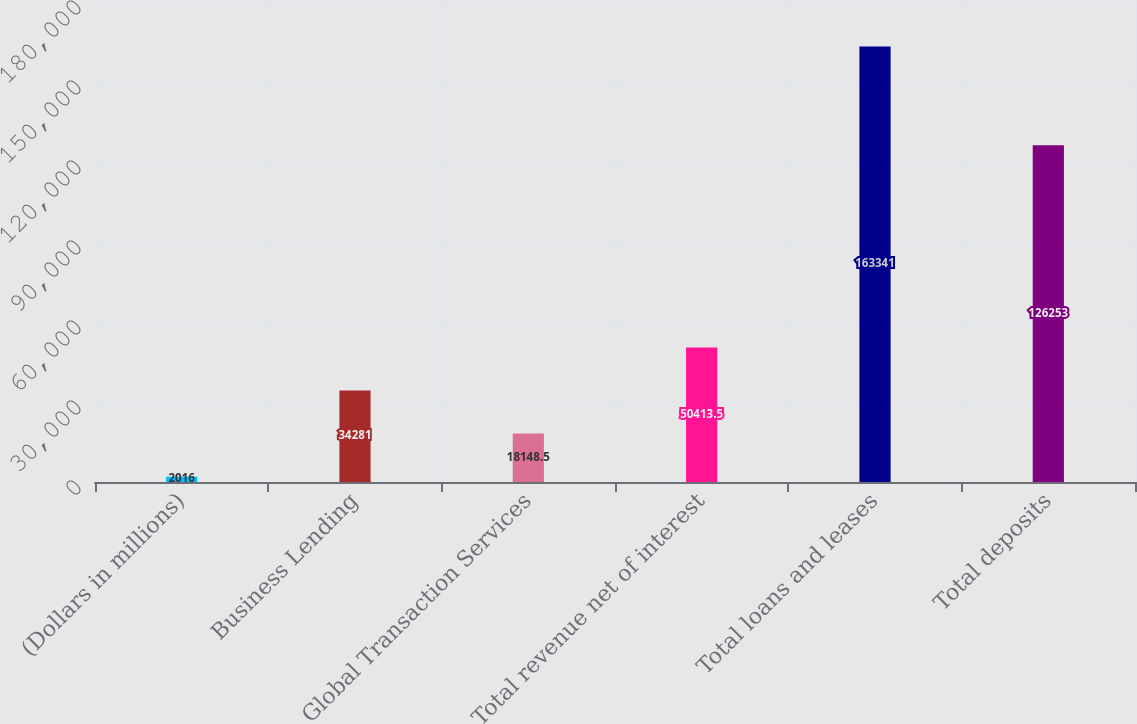Convert chart. <chart><loc_0><loc_0><loc_500><loc_500><bar_chart><fcel>(Dollars in millions)<fcel>Business Lending<fcel>Global Transaction Services<fcel>Total revenue net of interest<fcel>Total loans and leases<fcel>Total deposits<nl><fcel>2016<fcel>34281<fcel>18148.5<fcel>50413.5<fcel>163341<fcel>126253<nl></chart> 